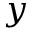<formula> <loc_0><loc_0><loc_500><loc_500>y</formula> 